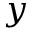<formula> <loc_0><loc_0><loc_500><loc_500>y</formula> 